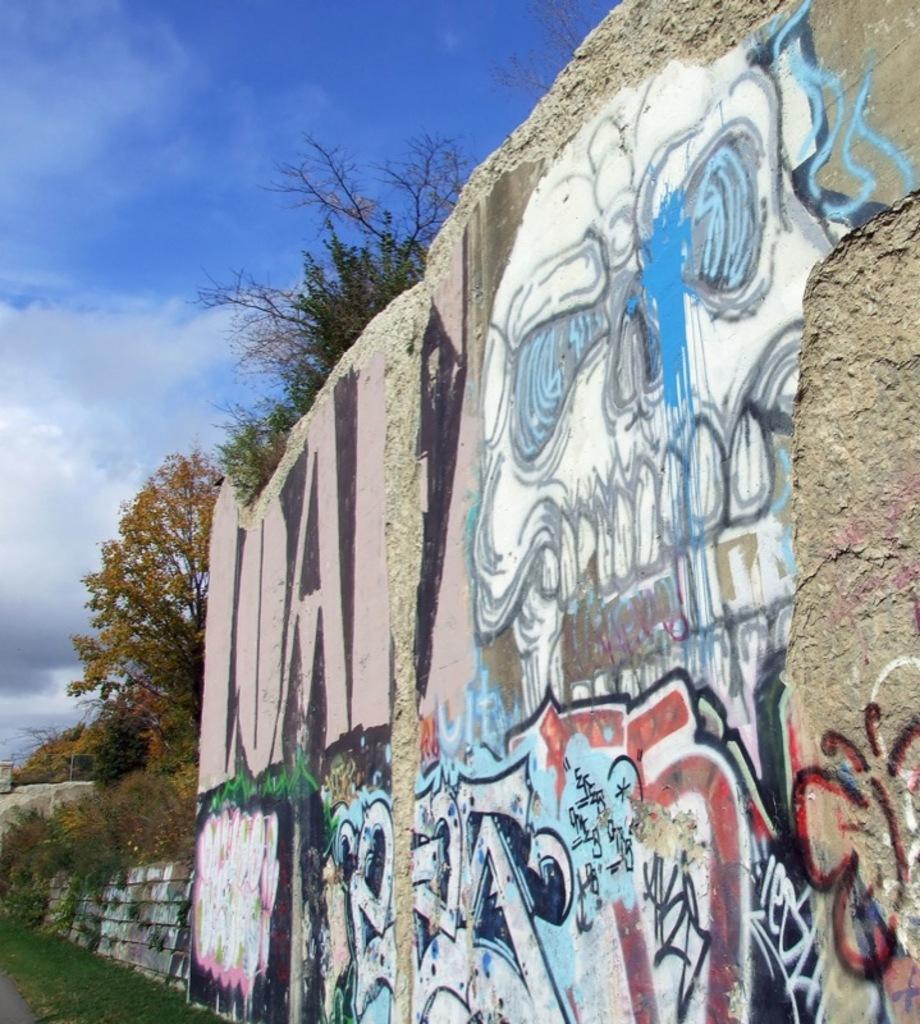Describe this image in one or two sentences. This picture is clicked outside. On the right there is an art of graffiti on the rock. On the left we can see the green grass, trees and the sky. 